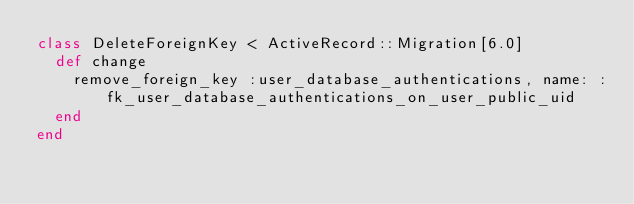<code> <loc_0><loc_0><loc_500><loc_500><_Ruby_>class DeleteForeignKey < ActiveRecord::Migration[6.0]
  def change
    remove_foreign_key :user_database_authentications, name: :fk_user_database_authentications_on_user_public_uid
  end
end
</code> 